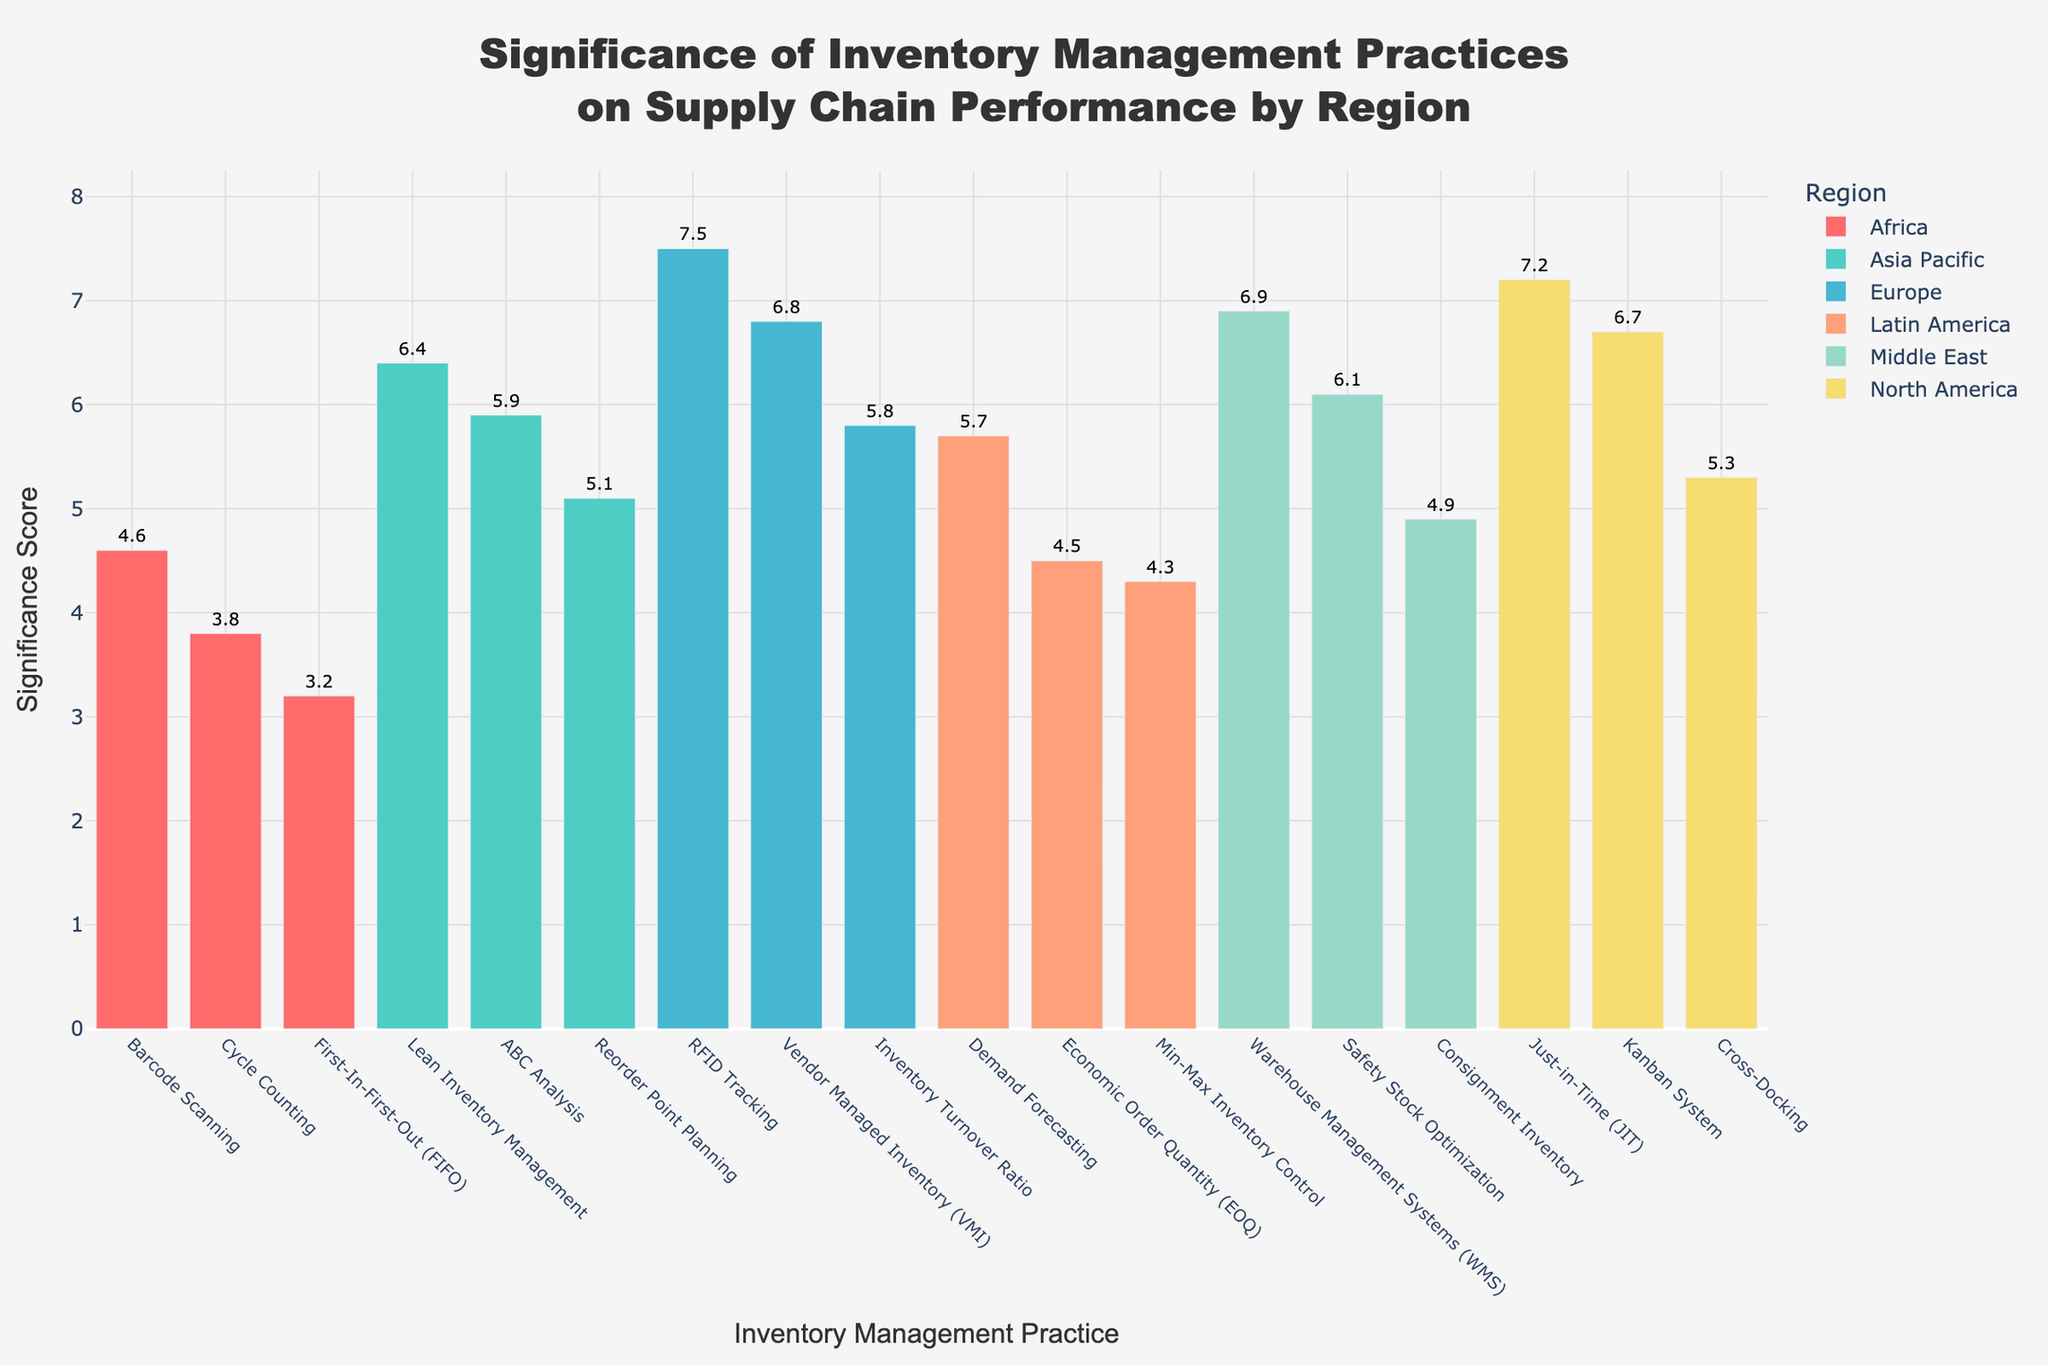What is the title of the plot? The title is typically found at the top of the plot and summarizes what the plot is about.
Answer: Significance of Inventory Management Practices on Supply Chain Performance by Region Which region has the highest significance score for a single practice? To determine this, I need to look at the bars and identify the region with the highest numeric value on the Y-axis. The highest value I observe is for Europe with RFID Tracking at 7.5.
Answer: Europe What is the average significance score of inventory management practices in North America? There are three data points for North America: 7.2 (JIT), 5.3 (Cross-Docking), and 6.7 (Kanban System). Sum them up and divide by 3: (7.2 + 5.3 + 6.7) / 3 = 19.2 / 3
Answer: 6.4 What is the range of significance scores for the practices in Africa? The range is calculated as the difference between the highest and lowest values. For Africa, the values are 3.8 (Cycle Counting) and 3.2 (FIFO). Therefore, the range is 3.8 - 3.2.
Answer: 0.6 Which practice has the lowest significance score and in which region? By scanning all the significance scores, the smallest value is 3.2, which corresponds to First-In-First-Out (FIFO) in Africa.
Answer: First-In-First-Out (FIFO) in Africa What's the sum of significance scores for Europe? Adding up the values for Europe: 6.8 (VMI), 7.5 (RFID Tracking), and 5.8 (Inventory Turnover Ratio), we get 6.8 + 7.5 + 5.8 = 20.1.
Answer: 20.1 Which inventory management practice has the highest significance score regardless of region? By looking at all the bars, the practice with the highest value is RFID Tracking in Europe with a significance score of 7.5.
Answer: RFID Tracking Europe Which region has the greatest variation in significance scores? Variation can be assessed as the range, which is the difference between the maximum and minimum values. For North America: 7.2 (JIT) - 5.3 (Cross-Docking) = 1.9, for Europe: 7.5 (RFID) - 5.8 (Inventory Turnover Ratio) = 1.7, for Asia Pacific: 6.4 (Lean) - 5.1 (Reorder planning) = 1.3, for Latin America: 5.7 (Demand Forecasting) - 4.3 (Min-Max) = 1.4, for Middle East: 6.9 (WMS) - 4.9 (Consignment) = 2.0, for Africa: 3.8 (Cycle Counting) - 3.2 (FIFO) = 0.6. Middle East has the greatest variation.
Answer: Middle East 